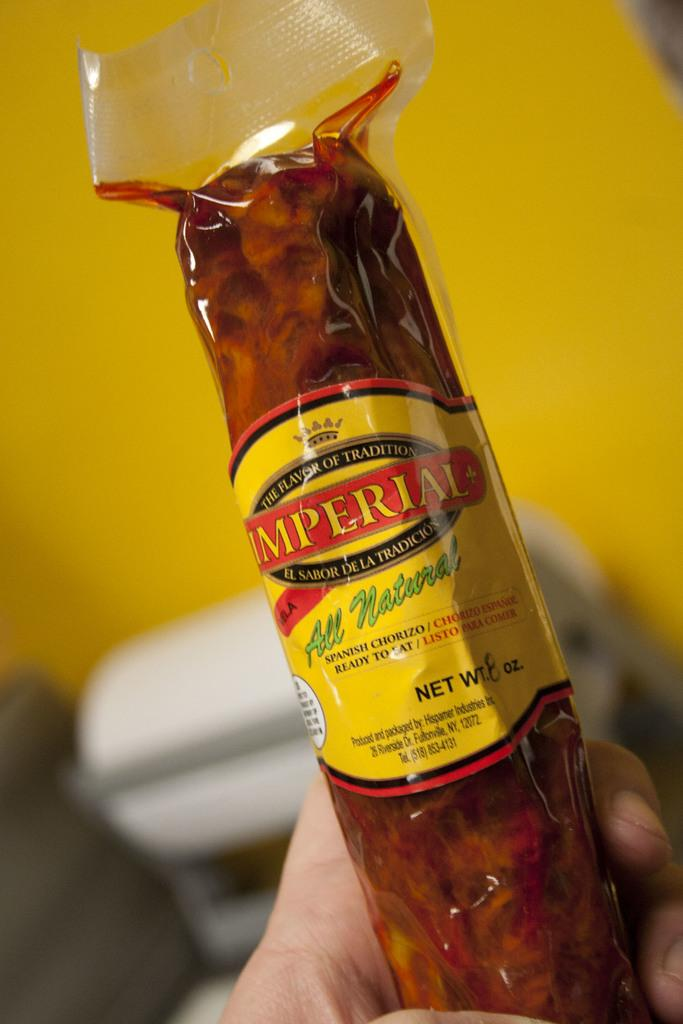<image>
Create a compact narrative representing the image presented. A person is holding a chorizo sausage wrapped in plastic. 